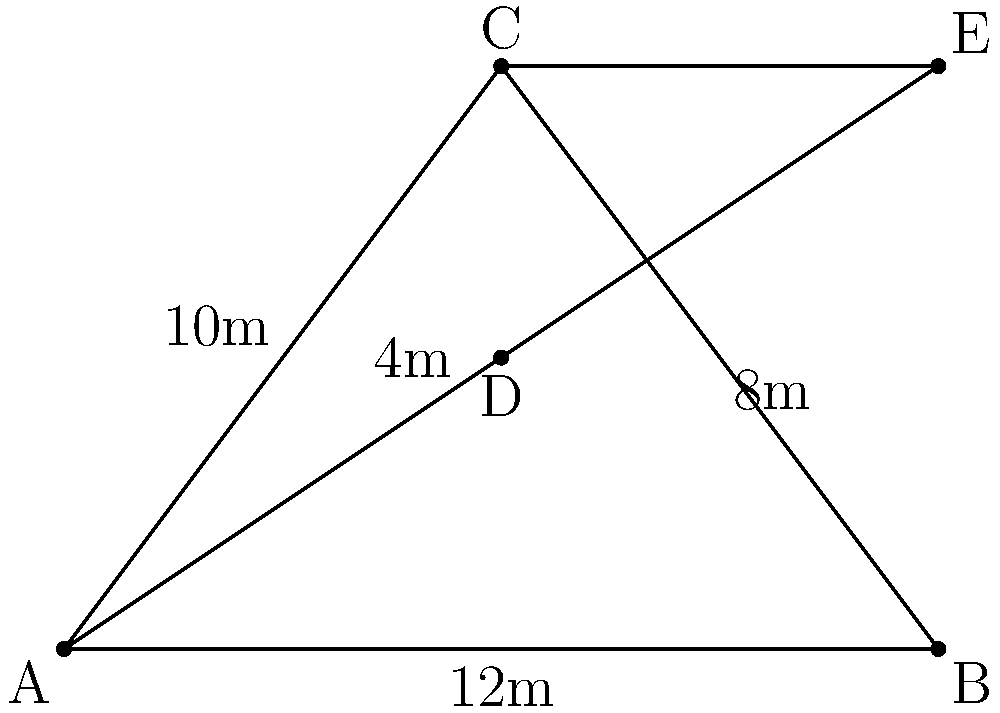As a traveling musician, you've been asked to design a unique triangular stage for an outdoor performance. The stage is represented by triangle ABC in the diagram. To add complexity, you decide to create two smaller stages within the main stage, forming triangles ACD and BCE. If the main stage has sides of 12m, 10m, and 8m, and CE is 4m, what is the area of the smaller stage BCE? Let's approach this step-by-step:

1) First, we need to find the area of the main stage (triangle ABC).
   We can use Heron's formula: $A = \sqrt{s(s-a)(s-b)(s-c)}$
   where $s = \frac{a+b+c}{2}$ (semi-perimeter)

2) $s = \frac{12+10+8}{2} = 15$

3) Area of ABC = $\sqrt{15(15-12)(15-10)(15-8)}$
                = $\sqrt{15 \cdot 3 \cdot 5 \cdot 7}$
                = $\sqrt{1575}$ = 39.69 m²

4) Now, we need to find the ratio of CE to BC to determine the area of BCE.
   BC = 8m, CE = 4m
   Ratio = 4:8 = 1:2

5) Since CE divides BC in the ratio 1:2, it also divides the height of the triangle in the same ratio.
   This means triangle BCE is similar to triangle ABC with a scale factor of 1/2.

6) The area of similar triangles is proportional to the square of their linear dimensions.
   So, Area of BCE = Area of ABC * (1/2)²
                   = 39.69 * 1/4
                   = 9.92 m²

Therefore, the area of the smaller stage BCE is approximately 9.92 m².
Answer: 9.92 m² 